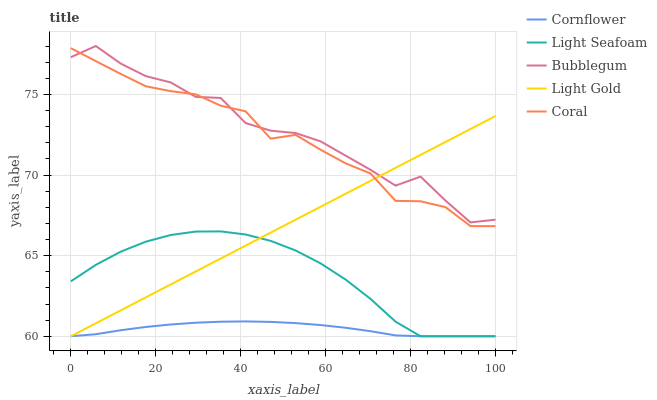Does Cornflower have the minimum area under the curve?
Answer yes or no. Yes. Does Bubblegum have the maximum area under the curve?
Answer yes or no. Yes. Does Coral have the minimum area under the curve?
Answer yes or no. No. Does Coral have the maximum area under the curve?
Answer yes or no. No. Is Light Gold the smoothest?
Answer yes or no. Yes. Is Bubblegum the roughest?
Answer yes or no. Yes. Is Coral the smoothest?
Answer yes or no. No. Is Coral the roughest?
Answer yes or no. No. Does Coral have the lowest value?
Answer yes or no. No. Does Bubblegum have the highest value?
Answer yes or no. Yes. Does Coral have the highest value?
Answer yes or no. No. Is Cornflower less than Bubblegum?
Answer yes or no. Yes. Is Bubblegum greater than Cornflower?
Answer yes or no. Yes. Does Light Gold intersect Light Seafoam?
Answer yes or no. Yes. Is Light Gold less than Light Seafoam?
Answer yes or no. No. Is Light Gold greater than Light Seafoam?
Answer yes or no. No. Does Cornflower intersect Bubblegum?
Answer yes or no. No. 